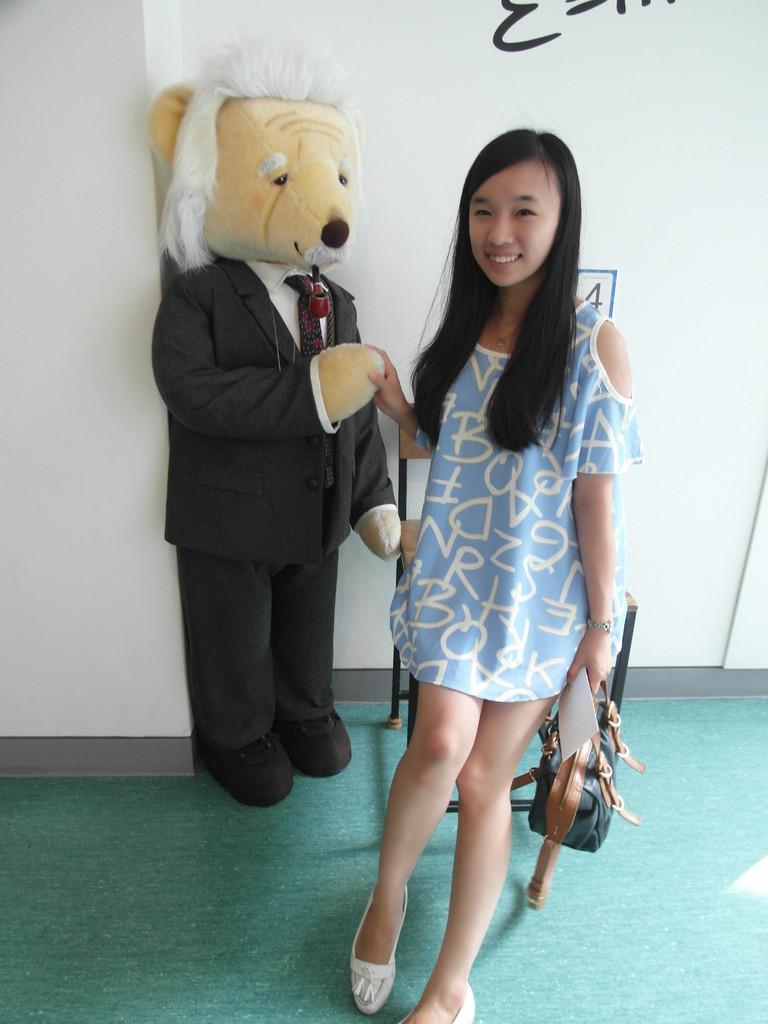Could you give a brief overview of what you see in this image? In this image we can see a girl standing on the ground holding a bag and some papers. On the backside we can see a chair, doll and some text on a wall. 